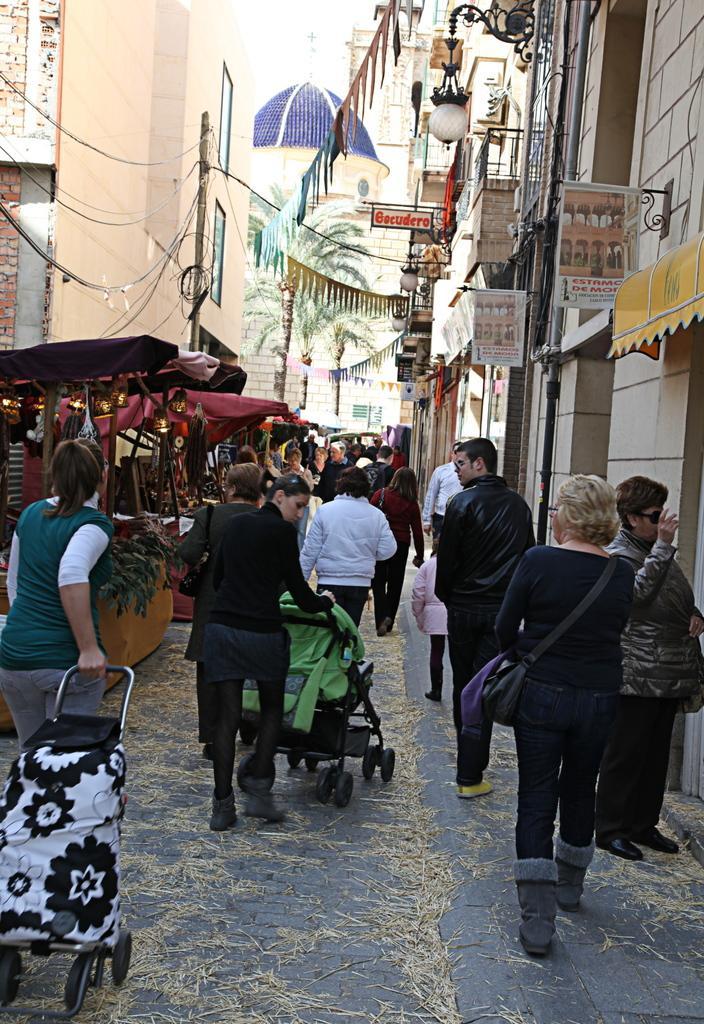Could you give a brief overview of what you see in this image? In the image we can see there are many people walking on the street, they are wearing clothes, these are the buildings, electric pole, electric wire, light, a handbag and a tree. 